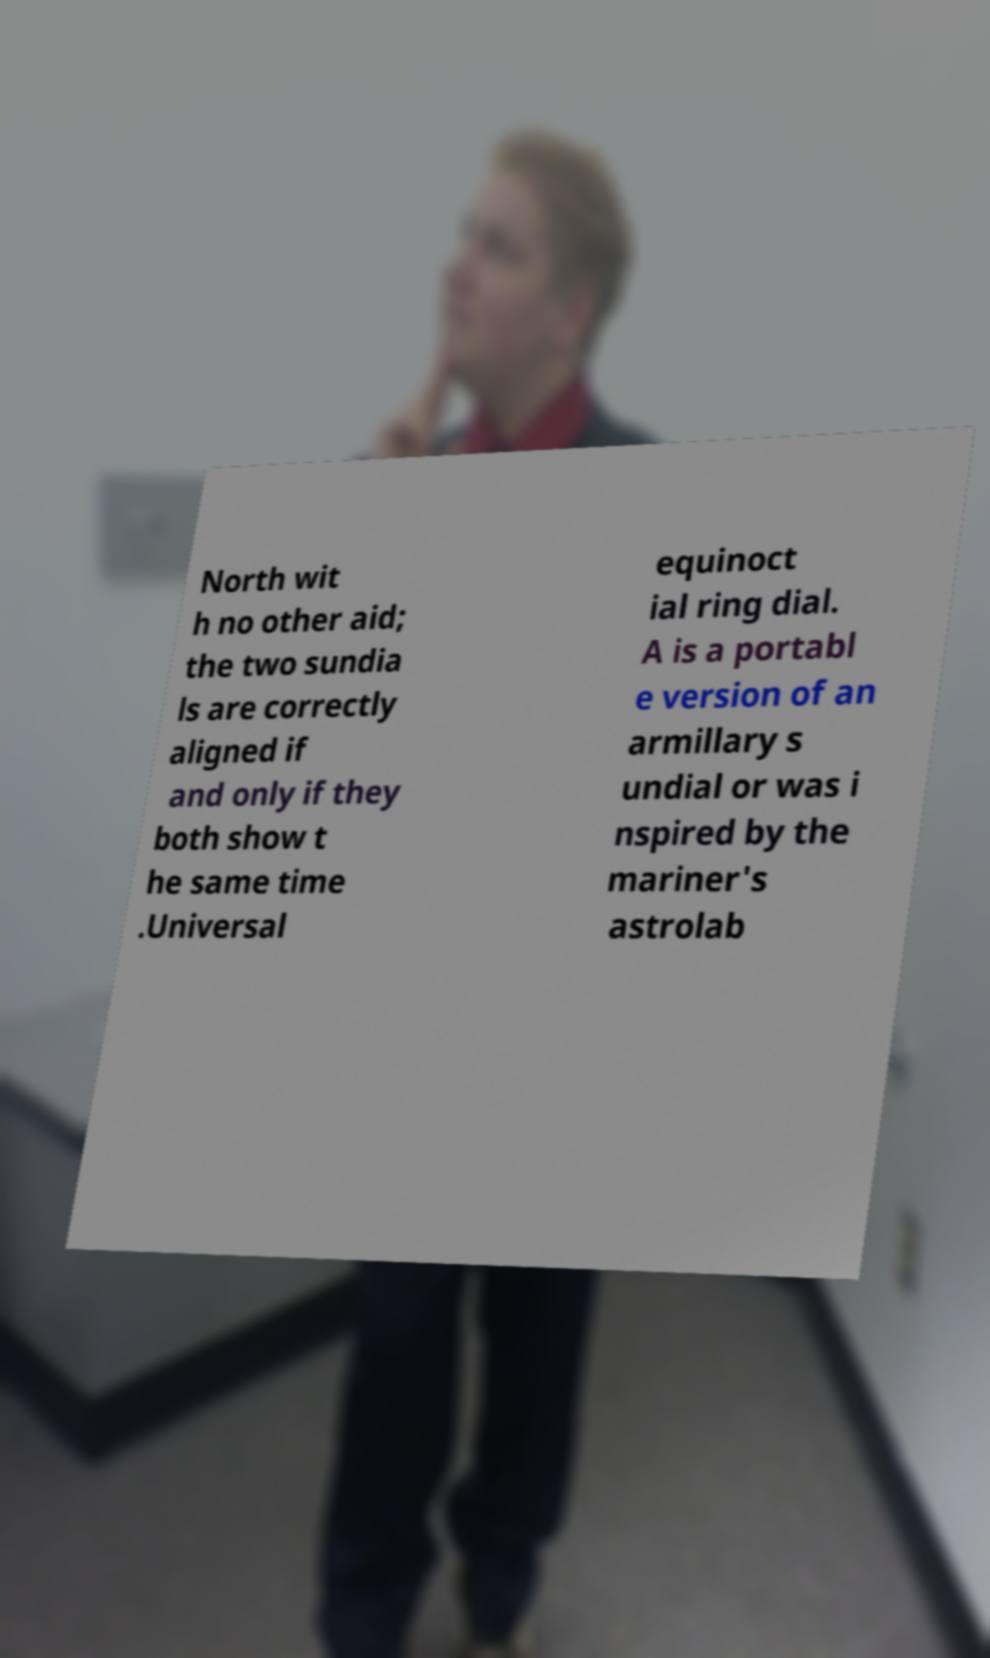Can you read and provide the text displayed in the image?This photo seems to have some interesting text. Can you extract and type it out for me? North wit h no other aid; the two sundia ls are correctly aligned if and only if they both show t he same time .Universal equinoct ial ring dial. A is a portabl e version of an armillary s undial or was i nspired by the mariner's astrolab 